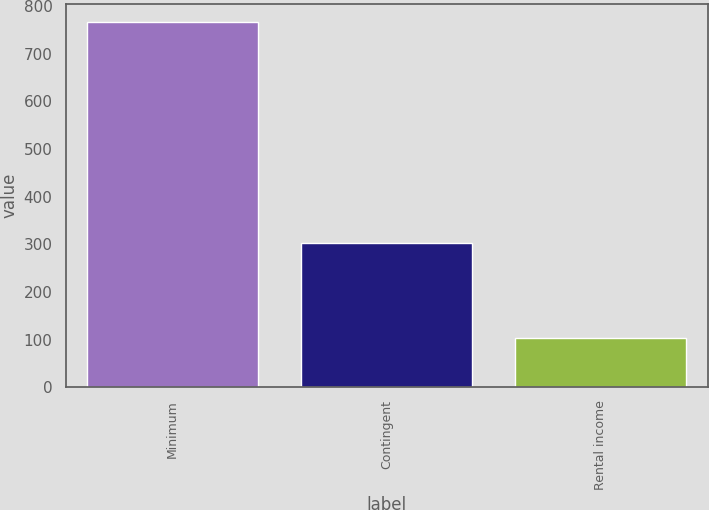Convert chart. <chart><loc_0><loc_0><loc_500><loc_500><bar_chart><fcel>Minimum<fcel>Contingent<fcel>Rental income<nl><fcel>766<fcel>302<fcel>103<nl></chart> 